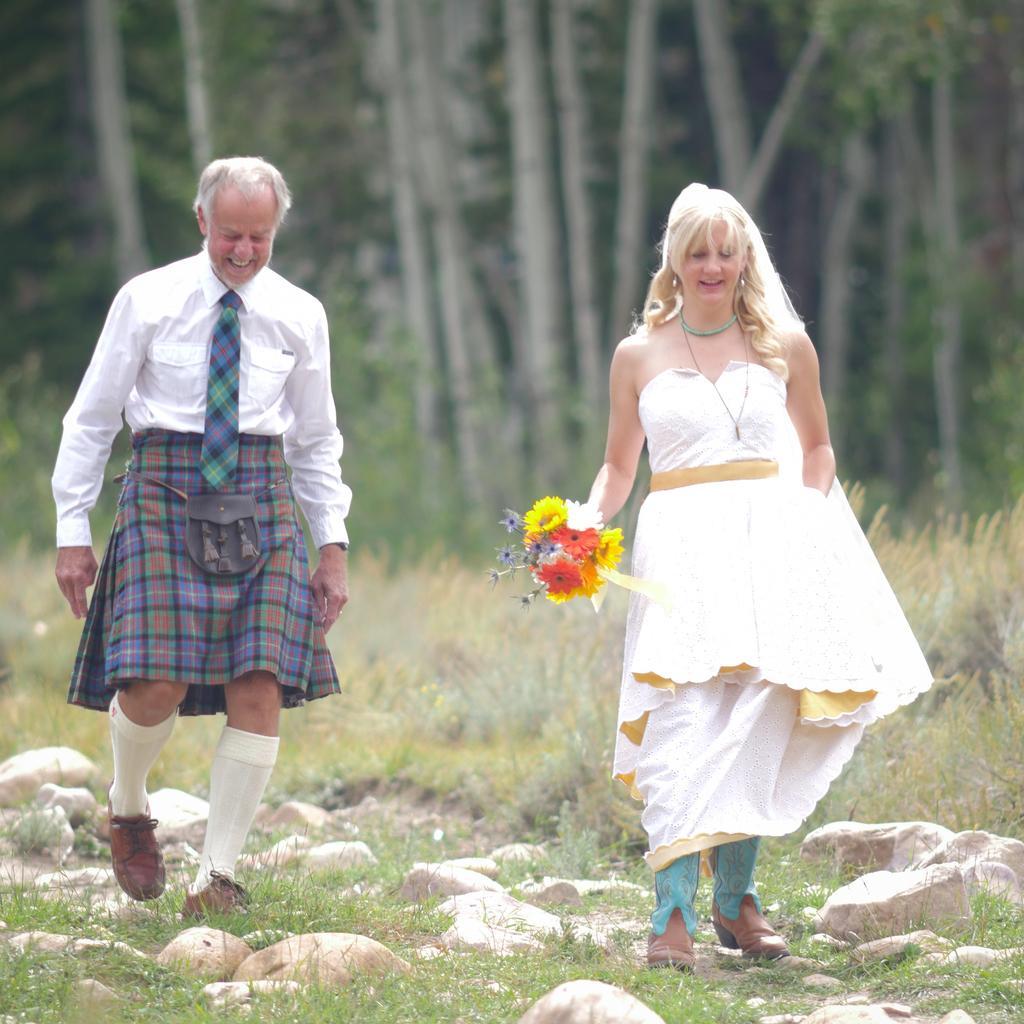How would you summarize this image in a sentence or two? In this image there are two persons walking and smiling , a person holding a flower bouquet , and there are rocks, grass, trees. 